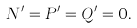<formula> <loc_0><loc_0><loc_500><loc_500>N ^ { \prime } = P ^ { \prime } = Q ^ { \prime } = 0 .</formula> 